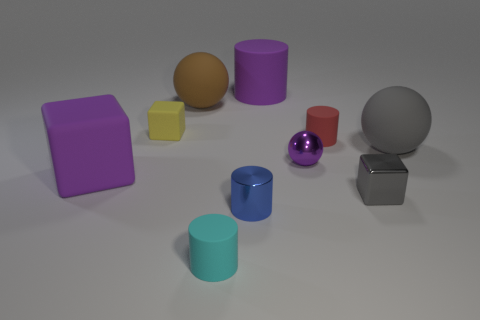There is a metal object that is the same color as the large cylinder; what shape is it?
Offer a terse response. Sphere. How many purple matte spheres are the same size as the red object?
Offer a terse response. 0. There is a tiny cylinder that is behind the metal cylinder; are there any small rubber objects in front of it?
Make the answer very short. Yes. What number of things are either large gray matte balls or small cylinders?
Provide a succinct answer. 4. What is the color of the metallic thing in front of the block in front of the big purple rubber object in front of the large gray rubber sphere?
Provide a short and direct response. Blue. Are there any other things that have the same color as the large cylinder?
Your answer should be very brief. Yes. Does the gray shiny object have the same size as the brown sphere?
Offer a very short reply. No. How many things are things that are behind the small yellow thing or matte balls that are behind the yellow matte cube?
Offer a terse response. 2. What is the gray thing that is behind the big thing left of the tiny yellow object made of?
Provide a succinct answer. Rubber. How many other things are there of the same material as the small cyan cylinder?
Provide a short and direct response. 6. 